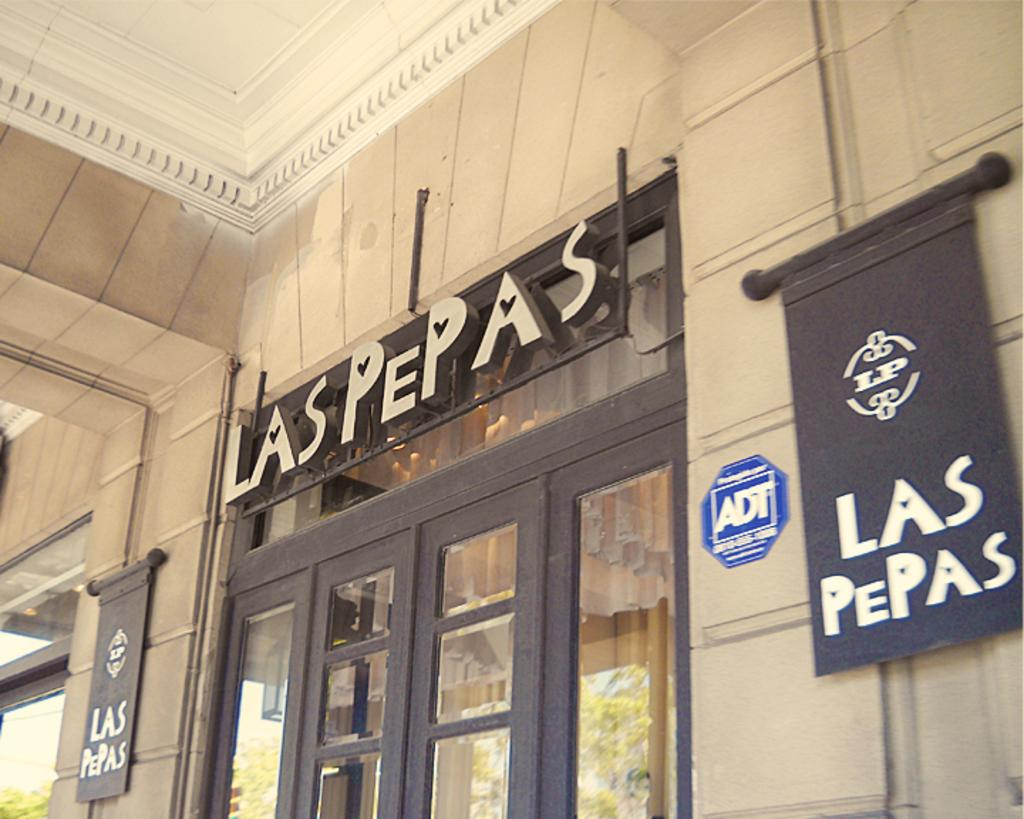What type of door is visible in the image? There is a glass door in the image. What is attached to the wall in the image? There are boards attached to the wall in the image. What can be seen in the reflection of the glass door? The reflection of trees is visible in the glass door. Is there a judge standing next to the glass door in the image? No, there is no judge present in the image. Can you see a girl playing with a vessel in the image? No, there is no girl or vessel present in the image. 